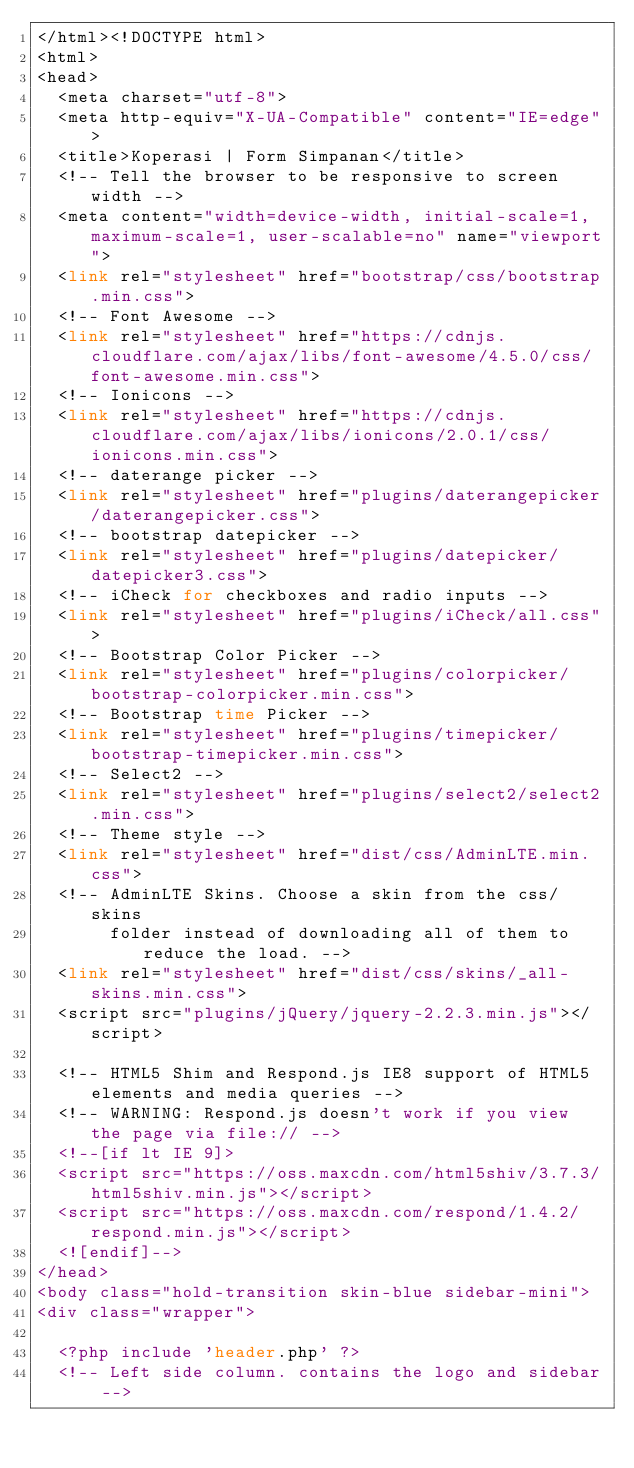Convert code to text. <code><loc_0><loc_0><loc_500><loc_500><_PHP_></html><!DOCTYPE html>
<html>
<head>
  <meta charset="utf-8">
  <meta http-equiv="X-UA-Compatible" content="IE=edge">
  <title>Koperasi | Form Simpanan</title>
  <!-- Tell the browser to be responsive to screen width -->
  <meta content="width=device-width, initial-scale=1, maximum-scale=1, user-scalable=no" name="viewport">
  <link rel="stylesheet" href="bootstrap/css/bootstrap.min.css">
  <!-- Font Awesome -->
  <link rel="stylesheet" href="https://cdnjs.cloudflare.com/ajax/libs/font-awesome/4.5.0/css/font-awesome.min.css">
  <!-- Ionicons -->
  <link rel="stylesheet" href="https://cdnjs.cloudflare.com/ajax/libs/ionicons/2.0.1/css/ionicons.min.css">
  <!-- daterange picker -->
  <link rel="stylesheet" href="plugins/daterangepicker/daterangepicker.css">
  <!-- bootstrap datepicker -->
  <link rel="stylesheet" href="plugins/datepicker/datepicker3.css">
  <!-- iCheck for checkboxes and radio inputs -->
  <link rel="stylesheet" href="plugins/iCheck/all.css">
  <!-- Bootstrap Color Picker -->
  <link rel="stylesheet" href="plugins/colorpicker/bootstrap-colorpicker.min.css">
  <!-- Bootstrap time Picker -->
  <link rel="stylesheet" href="plugins/timepicker/bootstrap-timepicker.min.css">
  <!-- Select2 -->
  <link rel="stylesheet" href="plugins/select2/select2.min.css">
  <!-- Theme style -->
  <link rel="stylesheet" href="dist/css/AdminLTE.min.css">
  <!-- AdminLTE Skins. Choose a skin from the css/skins
       folder instead of downloading all of them to reduce the load. -->
  <link rel="stylesheet" href="dist/css/skins/_all-skins.min.css">
  <script src="plugins/jQuery/jquery-2.2.3.min.js"></script>

  <!-- HTML5 Shim and Respond.js IE8 support of HTML5 elements and media queries -->
  <!-- WARNING: Respond.js doesn't work if you view the page via file:// -->
  <!--[if lt IE 9]>
  <script src="https://oss.maxcdn.com/html5shiv/3.7.3/html5shiv.min.js"></script>
  <script src="https://oss.maxcdn.com/respond/1.4.2/respond.min.js"></script>
  <![endif]-->
</head>
<body class="hold-transition skin-blue sidebar-mini">
<div class="wrapper">

  <?php include 'header.php' ?>
  <!-- Left side column. contains the logo and sidebar --></code> 